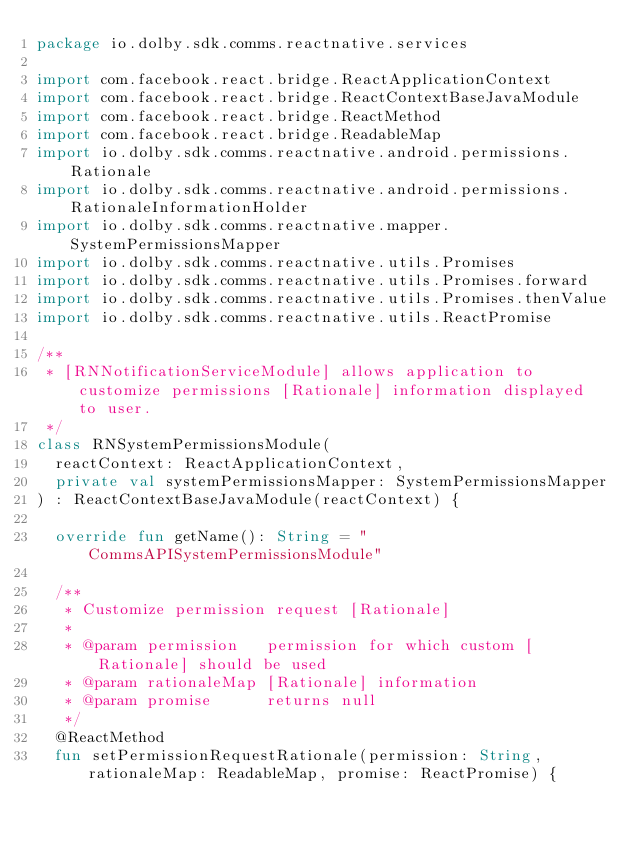<code> <loc_0><loc_0><loc_500><loc_500><_Kotlin_>package io.dolby.sdk.comms.reactnative.services

import com.facebook.react.bridge.ReactApplicationContext
import com.facebook.react.bridge.ReactContextBaseJavaModule
import com.facebook.react.bridge.ReactMethod
import com.facebook.react.bridge.ReadableMap
import io.dolby.sdk.comms.reactnative.android.permissions.Rationale
import io.dolby.sdk.comms.reactnative.android.permissions.RationaleInformationHolder
import io.dolby.sdk.comms.reactnative.mapper.SystemPermissionsMapper
import io.dolby.sdk.comms.reactnative.utils.Promises
import io.dolby.sdk.comms.reactnative.utils.Promises.forward
import io.dolby.sdk.comms.reactnative.utils.Promises.thenValue
import io.dolby.sdk.comms.reactnative.utils.ReactPromise

/**
 * [RNNotificationServiceModule] allows application to customize permissions [Rationale] information displayed to user.
 */
class RNSystemPermissionsModule(
  reactContext: ReactApplicationContext,
  private val systemPermissionsMapper: SystemPermissionsMapper
) : ReactContextBaseJavaModule(reactContext) {

  override fun getName(): String = "CommsAPISystemPermissionsModule"

  /**
   * Customize permission request [Rationale]
   *
   * @param permission   permission for which custom [Rationale] should be used
   * @param rationaleMap [Rationale] information
   * @param promise      returns null
   */
  @ReactMethod
  fun setPermissionRequestRationale(permission: String, rationaleMap: ReadableMap, promise: ReactPromise) {</code> 